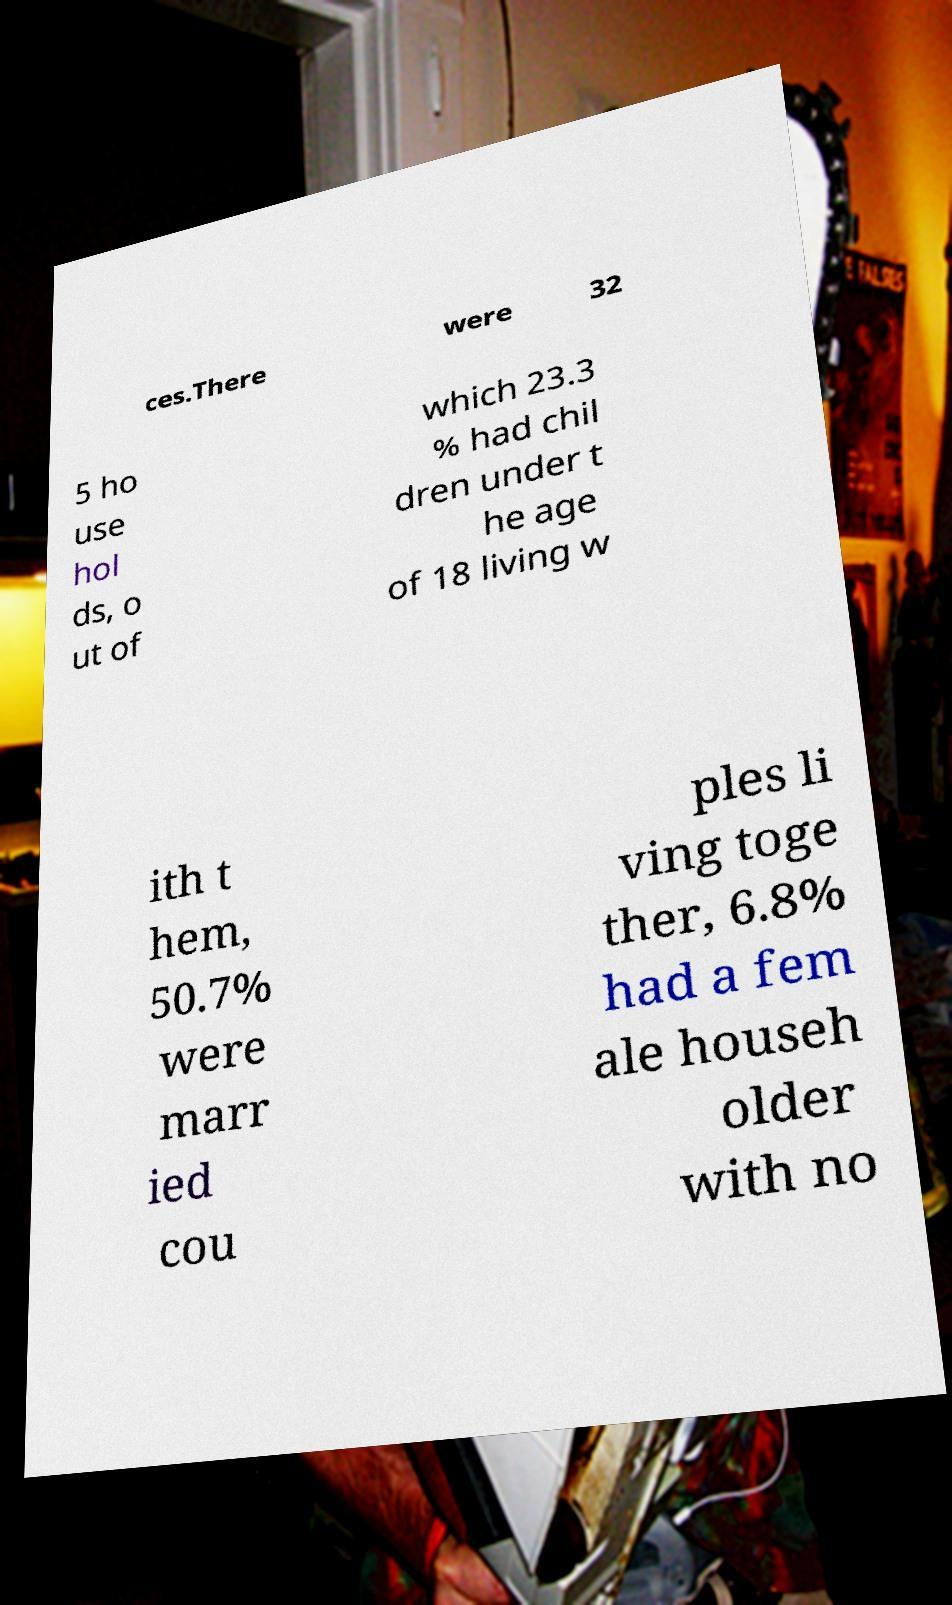Please read and relay the text visible in this image. What does it say? ces.There were 32 5 ho use hol ds, o ut of which 23.3 % had chil dren under t he age of 18 living w ith t hem, 50.7% were marr ied cou ples li ving toge ther, 6.8% had a fem ale househ older with no 